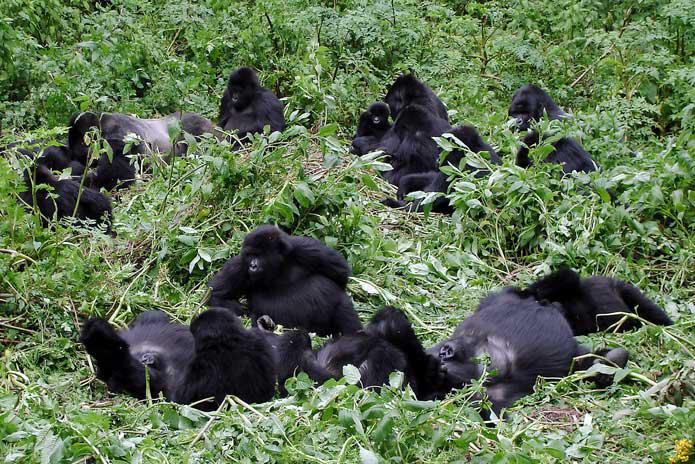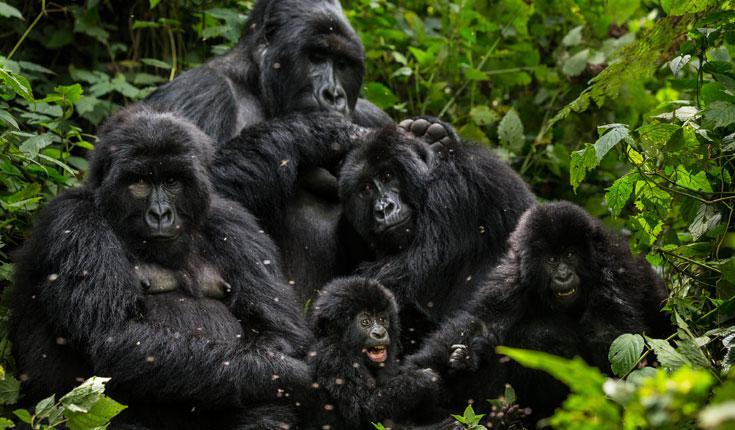The first image is the image on the left, the second image is the image on the right. Assess this claim about the two images: "There's no more than four gorillas in the right image.". Correct or not? Answer yes or no. No. The first image is the image on the left, the second image is the image on the right. Given the left and right images, does the statement "There are six gorillas in the image pair." hold true? Answer yes or no. No. 